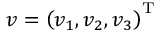Convert formula to latex. <formula><loc_0><loc_0><loc_500><loc_500>v = \left ( v _ { 1 } , v _ { 2 } , v _ { 3 } \right ) ^ { T }</formula> 